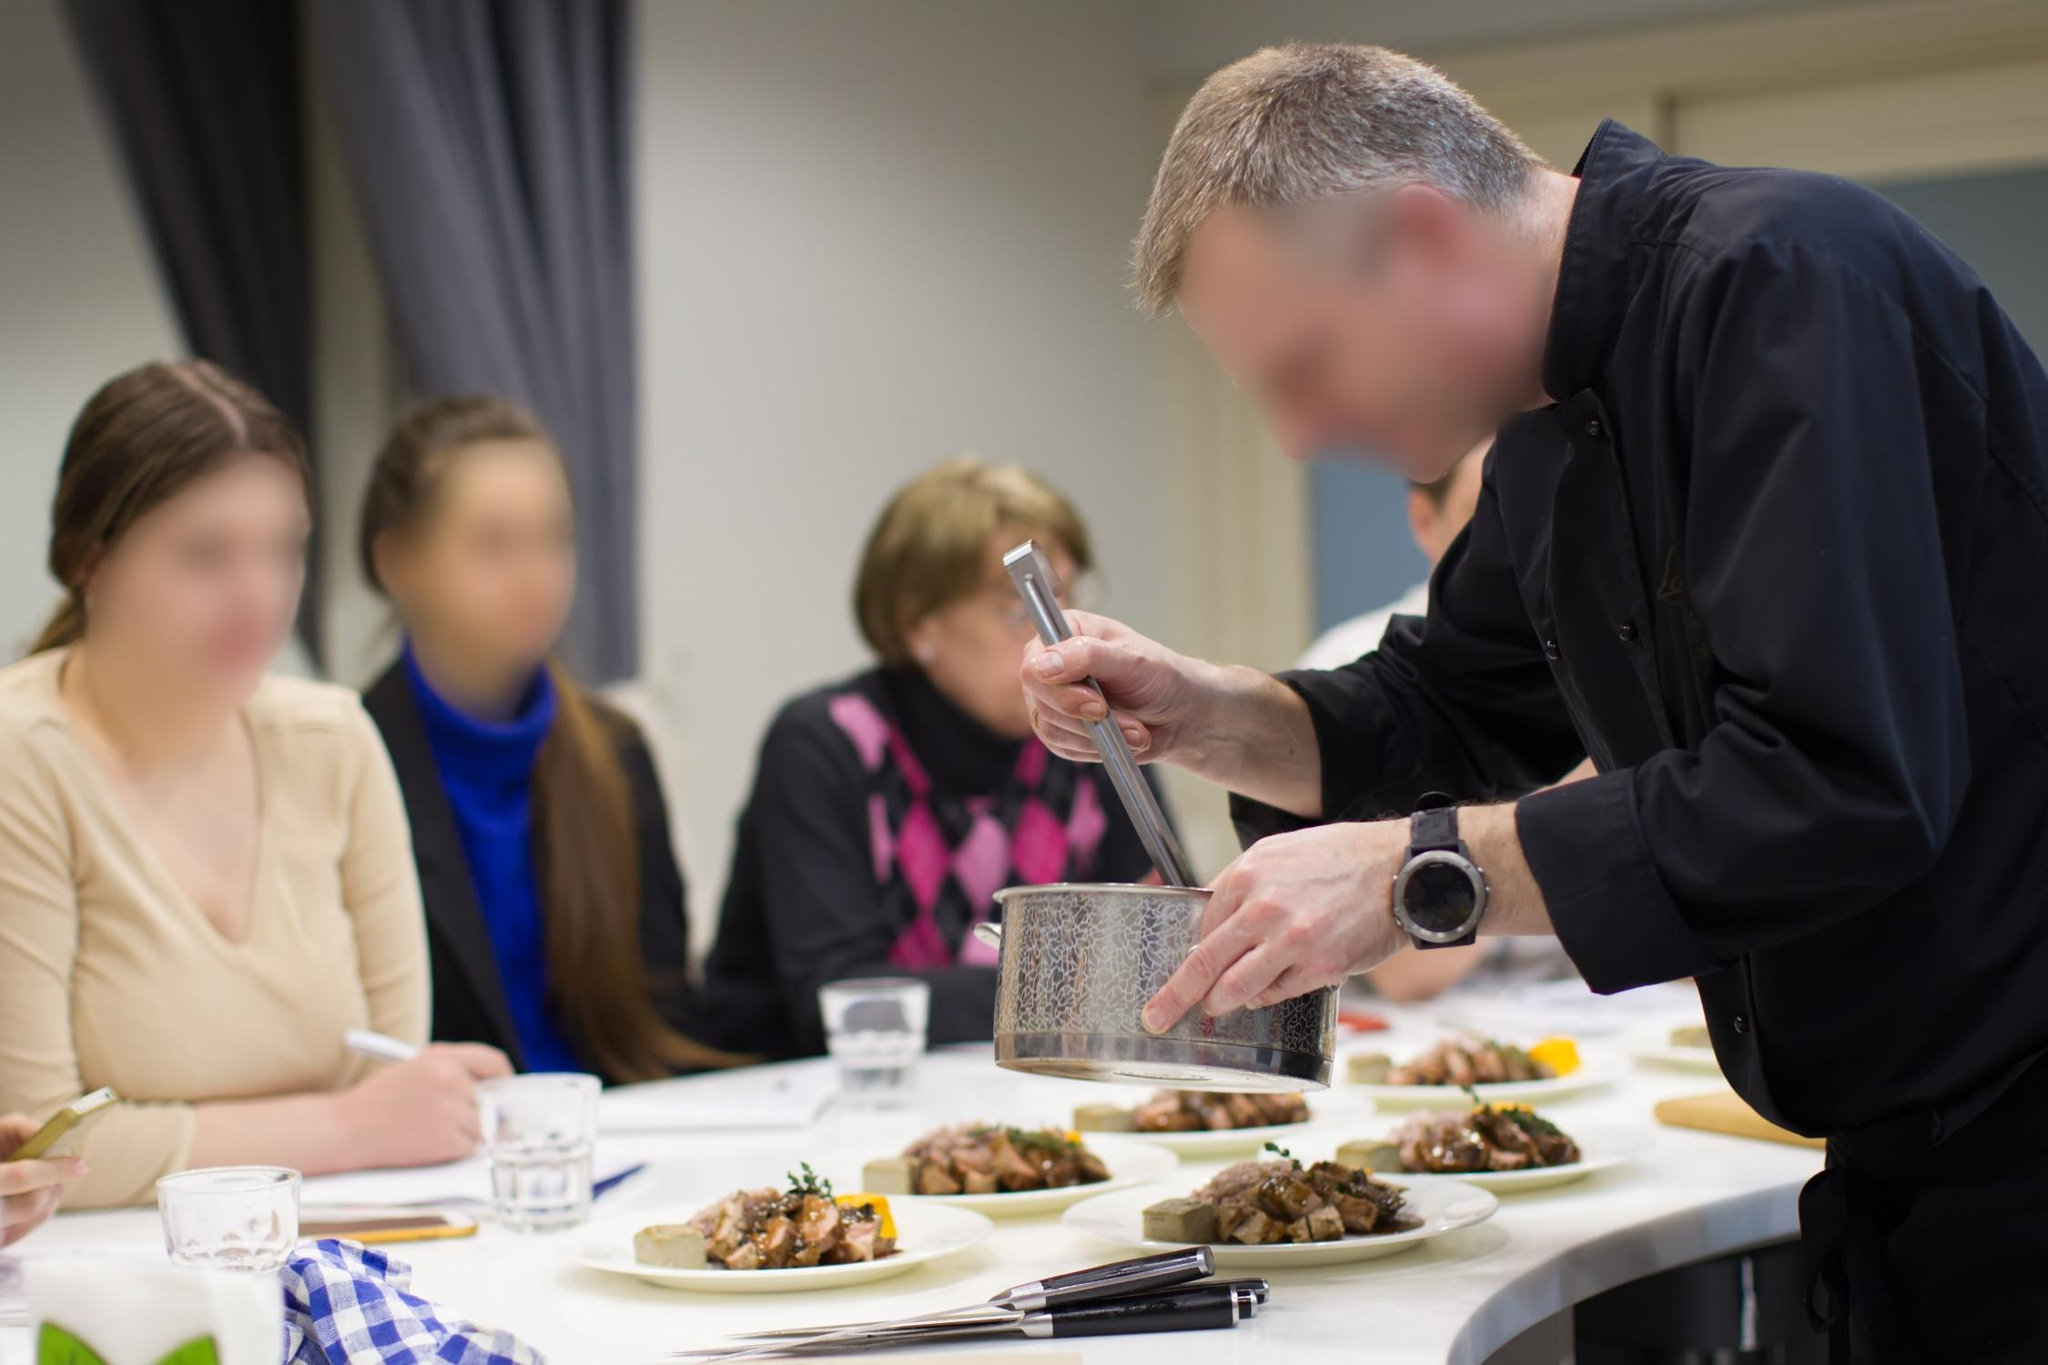What is the mood of the image? The mood of the image is engaging and educational, with an undertone of anticipation and enthusiasm. The focused expression of the chef and the attentive posture of the spectators convey a sense of shared purpose and passion for culinary arts. This collaborative atmosphere promotes learning and interaction, making the experience enjoyable and valuable for everyone involved. 